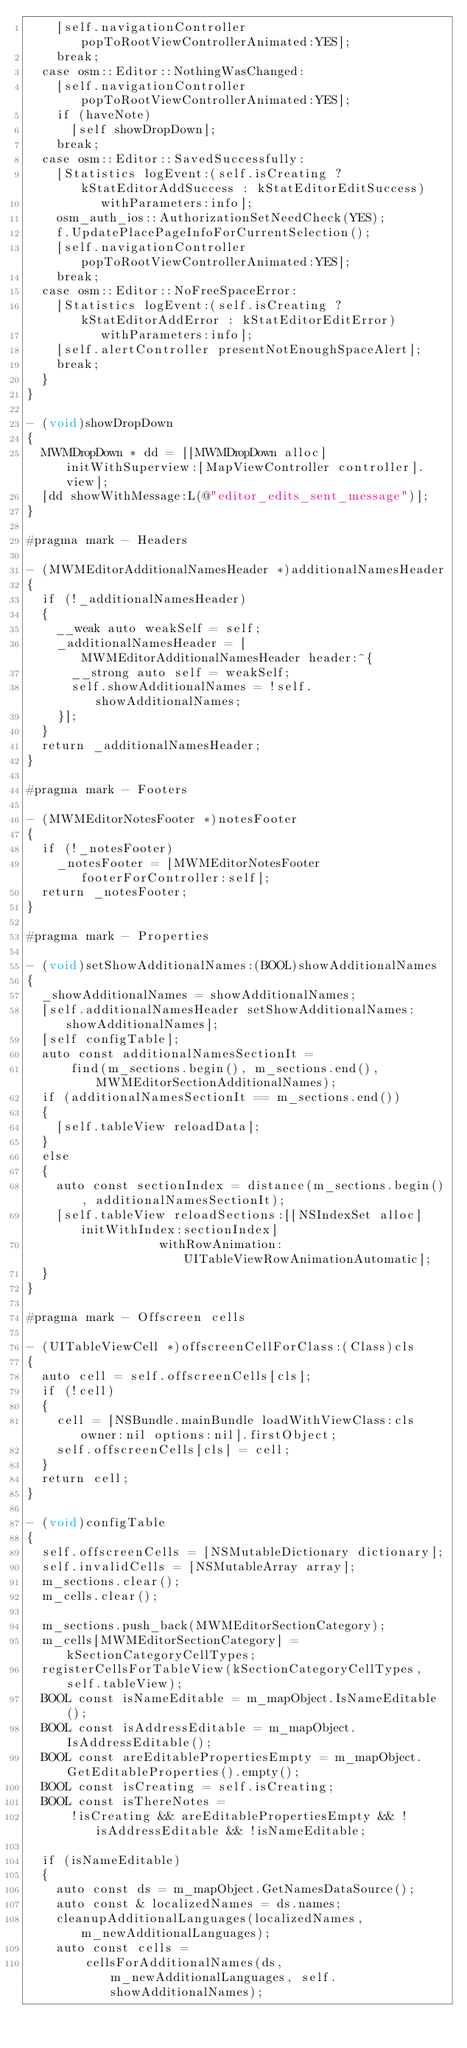<code> <loc_0><loc_0><loc_500><loc_500><_ObjectiveC_>    [self.navigationController popToRootViewControllerAnimated:YES];
    break;
  case osm::Editor::NothingWasChanged:
    [self.navigationController popToRootViewControllerAnimated:YES];
    if (haveNote)
      [self showDropDown];
    break;
  case osm::Editor::SavedSuccessfully:
    [Statistics logEvent:(self.isCreating ? kStatEditorAddSuccess : kStatEditorEditSuccess)
          withParameters:info];
    osm_auth_ios::AuthorizationSetNeedCheck(YES);
    f.UpdatePlacePageInfoForCurrentSelection();
    [self.navigationController popToRootViewControllerAnimated:YES];
    break;
  case osm::Editor::NoFreeSpaceError:
    [Statistics logEvent:(self.isCreating ? kStatEditorAddError : kStatEditorEditError)
          withParameters:info];
    [self.alertController presentNotEnoughSpaceAlert];
    break;
  }
}

- (void)showDropDown
{
  MWMDropDown * dd = [[MWMDropDown alloc] initWithSuperview:[MapViewController controller].view];
  [dd showWithMessage:L(@"editor_edits_sent_message")];
}

#pragma mark - Headers

- (MWMEditorAdditionalNamesHeader *)additionalNamesHeader
{
  if (!_additionalNamesHeader)
  {
    __weak auto weakSelf = self;
    _additionalNamesHeader = [MWMEditorAdditionalNamesHeader header:^{
      __strong auto self = weakSelf;
      self.showAdditionalNames = !self.showAdditionalNames;
    }];
  }
  return _additionalNamesHeader;
}

#pragma mark - Footers

- (MWMEditorNotesFooter *)notesFooter
{
  if (!_notesFooter)
    _notesFooter = [MWMEditorNotesFooter footerForController:self];
  return _notesFooter;
}

#pragma mark - Properties

- (void)setShowAdditionalNames:(BOOL)showAdditionalNames
{
  _showAdditionalNames = showAdditionalNames;
  [self.additionalNamesHeader setShowAdditionalNames:showAdditionalNames];
  [self configTable];
  auto const additionalNamesSectionIt =
      find(m_sections.begin(), m_sections.end(), MWMEditorSectionAdditionalNames);
  if (additionalNamesSectionIt == m_sections.end())
  {
    [self.tableView reloadData];
  }
  else
  {
    auto const sectionIndex = distance(m_sections.begin(), additionalNamesSectionIt);
    [self.tableView reloadSections:[[NSIndexSet alloc] initWithIndex:sectionIndex]
                  withRowAnimation:UITableViewRowAnimationAutomatic];
  }
}

#pragma mark - Offscreen cells

- (UITableViewCell *)offscreenCellForClass:(Class)cls
{
  auto cell = self.offscreenCells[cls];
  if (!cell)
  {
    cell = [NSBundle.mainBundle loadWithViewClass:cls owner:nil options:nil].firstObject;
    self.offscreenCells[cls] = cell;
  }
  return cell;
}

- (void)configTable
{
  self.offscreenCells = [NSMutableDictionary dictionary];
  self.invalidCells = [NSMutableArray array];
  m_sections.clear();
  m_cells.clear();

  m_sections.push_back(MWMEditorSectionCategory);
  m_cells[MWMEditorSectionCategory] = kSectionCategoryCellTypes;
  registerCellsForTableView(kSectionCategoryCellTypes, self.tableView);
  BOOL const isNameEditable = m_mapObject.IsNameEditable();
  BOOL const isAddressEditable = m_mapObject.IsAddressEditable();
  BOOL const areEditablePropertiesEmpty = m_mapObject.GetEditableProperties().empty();
  BOOL const isCreating = self.isCreating;
  BOOL const isThereNotes =
      !isCreating && areEditablePropertiesEmpty && !isAddressEditable && !isNameEditable;

  if (isNameEditable)
  {
    auto const ds = m_mapObject.GetNamesDataSource();
    auto const & localizedNames = ds.names;
    cleanupAdditionalLanguages(localizedNames, m_newAdditionalLanguages);
    auto const cells =
        cellsForAdditionalNames(ds, m_newAdditionalLanguages, self.showAdditionalNames);</code> 